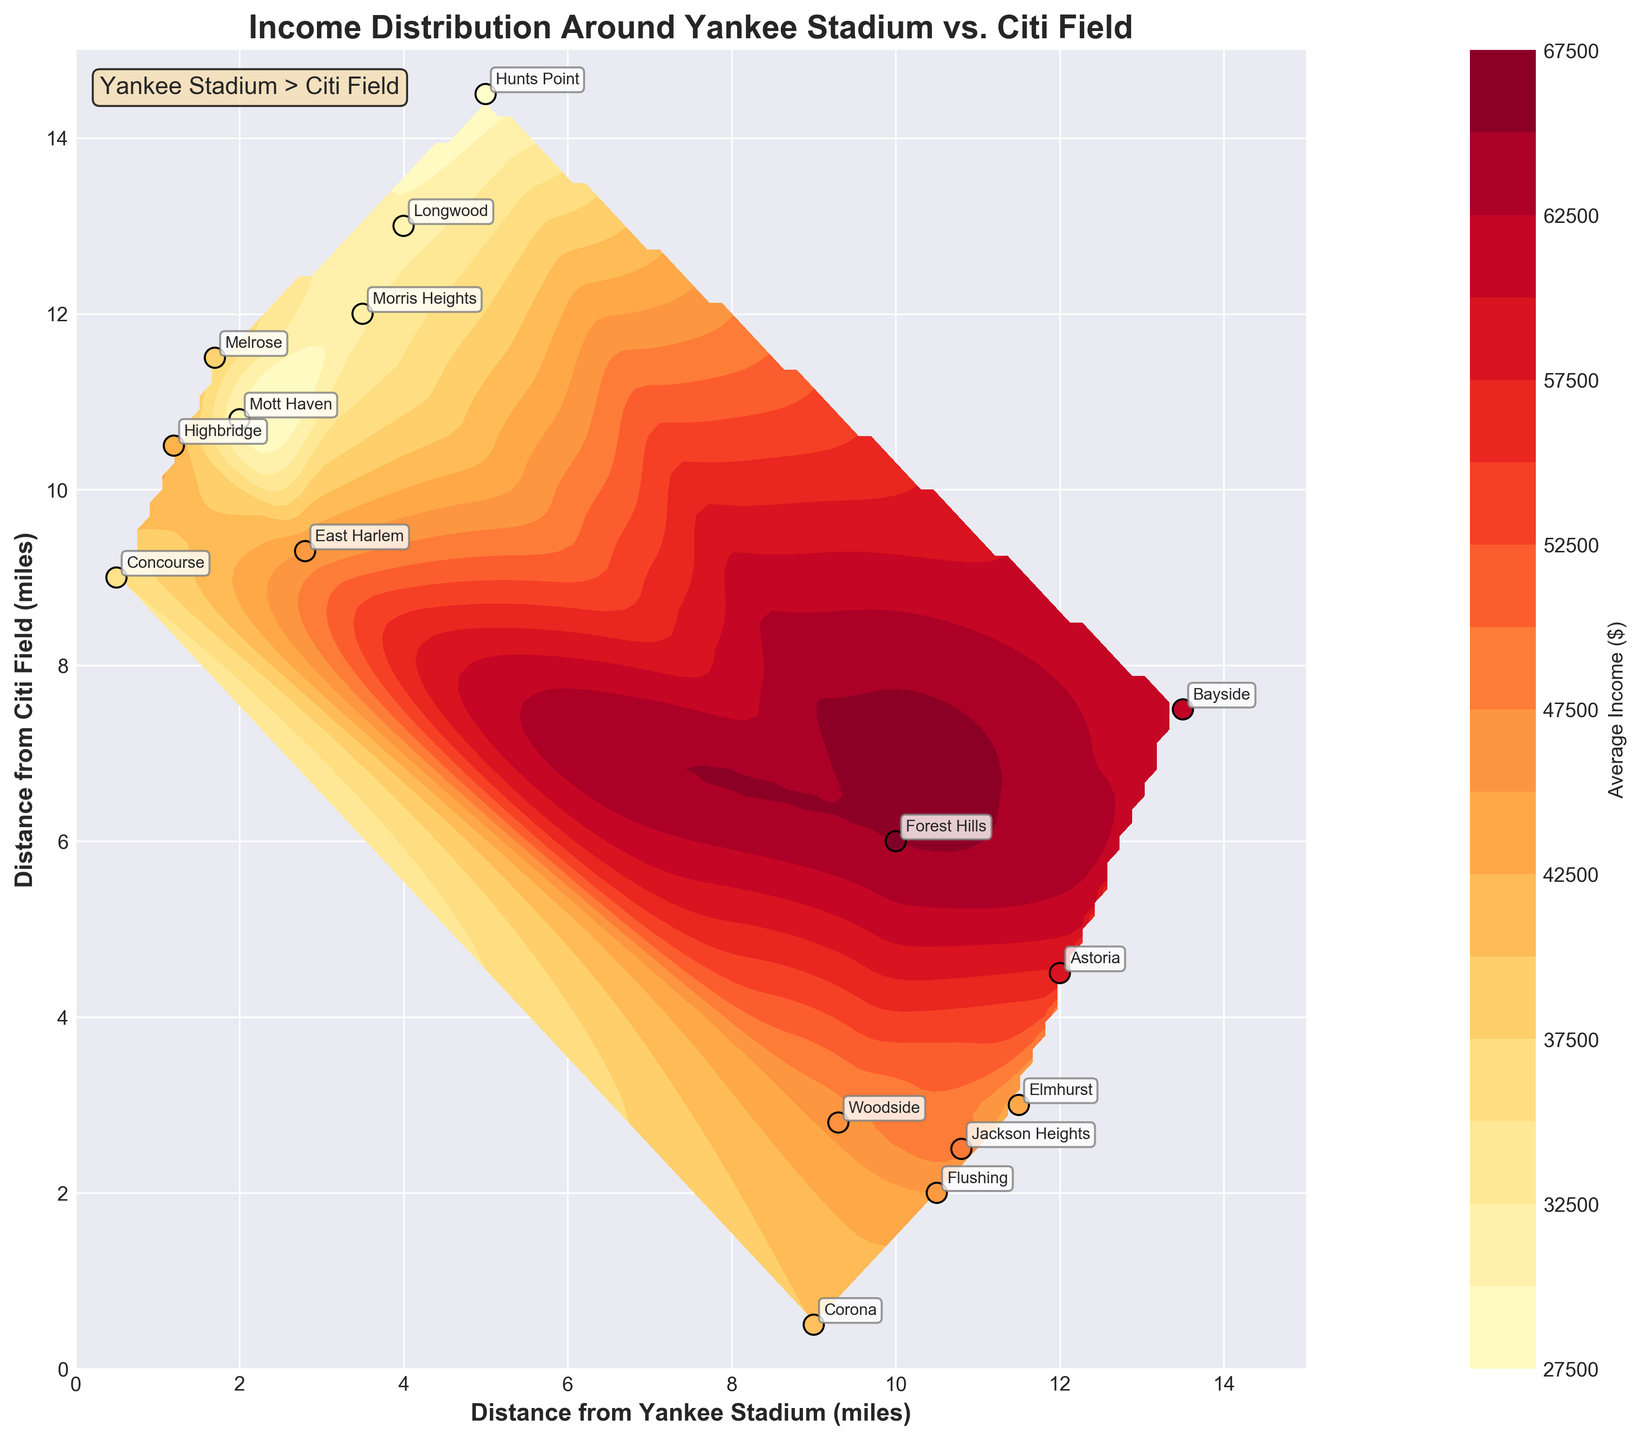What's the title of the plot? The title is usually found at the top of the figure, indicating what the plot represents.
Answer: Income Distribution Around Yankee Stadium vs. Citi Field How many neighborhoods are labeled on the contour plot? Count the number of unique labels annotated on the plot that represent different neighborhoods.
Answer: 16 Which neighborhood has the highest average income and what is that income? Identify the neighborhood with the highest value in the color range or refer to the data points annotated with their income values.
Answer: Forest Hills at $65,000 Which neighborhood is closest to Yankee Stadium? Check the point on the plot with the smallest distance to Yankee Stadium on the x-axis.
Answer: Concourse What is the general trend of income as the distance from Yankee Stadium increases? Look at how the contour colors change as the x-axis value increases to identify the income trend.
Answer: The general trend shows no clear pattern; income varies across different distances Compare the average incomes of neighborhoods closest to Yankee Stadium and Citi Field. Identify the neighborhoods close to each stadium and compare their noted average incomes. For Yankee Stadium, these are Concourse, Highbridge, and Mott Haven. For Citi Field, these are Corona, Flushing, and Jackson Heights.
Answer: Yankee Stadium: Concourse $35K, Highbridge $42K, Mott Haven $30K. Citi Field: Corona $40K, Flushing $45K, Jackson Heights $48K Which neighborhood is approximately equidistant from Yankee Stadium and Citi Field, and what is its average income? Find the point(s) where the x and y coordinates are roughly the same and note the income.
Answer: East Harlem ($45,000) How does the income distribution around Citi Field compare to Yankee Stadium in terms of neighborhood variations? Compare the variance in income levels around each stadium by looking at the spread of income data points near each.
Answer: More variations near Citi Field What's the distance gap between the neighborhoods with the highest and lowest average incomes from both stadiums? Identify the neighborhoods with the highest and lowest incomes and note their distances from both stadiums. Calculate the differences. Neighborhood with highest income is Forest Hills ($65K, 10.0 miles from Yankee Stadium, 6.0 miles from Citi Field). Neighborhood with lowest income is Hunts Point ($28K, 5.0 miles from Yankee Stadium, 14.5 miles from Citi Field). Distance gap: For Yankee Stadium: 10.0 - 5.0 = 5.0 miles. For Citi Field: 14.5 - 6.0 = 8.5 miles.
Answer: Yankee Stadium: 5.0 miles, Citi Field: 8.5 miles What color on the contour plot represents the lowest average income range? Identify the color used in the contour plot legend for the lowest income bracket.
Answer: Light Yellow 